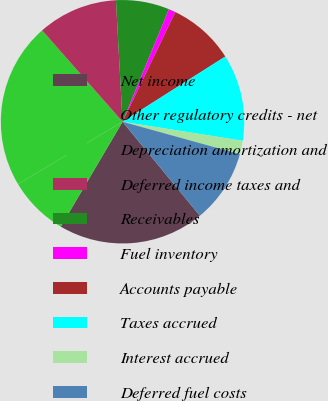Convert chart to OTSL. <chart><loc_0><loc_0><loc_500><loc_500><pie_chart><fcel>Net income<fcel>Other regulatory credits - net<fcel>Depreciation amortization and<fcel>Deferred income taxes and<fcel>Receivables<fcel>Fuel inventory<fcel>Accounts payable<fcel>Taxes accrued<fcel>Interest accrued<fcel>Deferred fuel costs<nl><fcel>19.43%<fcel>7.97%<fcel>22.07%<fcel>10.62%<fcel>7.09%<fcel>0.92%<fcel>8.85%<fcel>11.5%<fcel>1.8%<fcel>9.74%<nl></chart> 